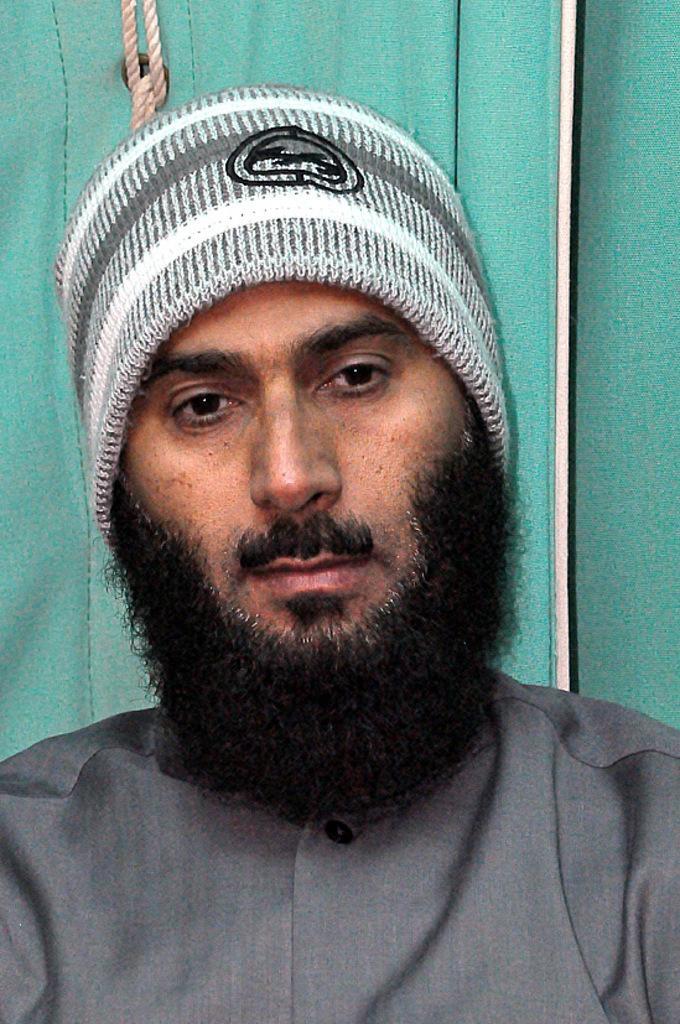Please provide a concise description of this image. In this image we can see a person wearing a hat. On the backside we can see a rope. 